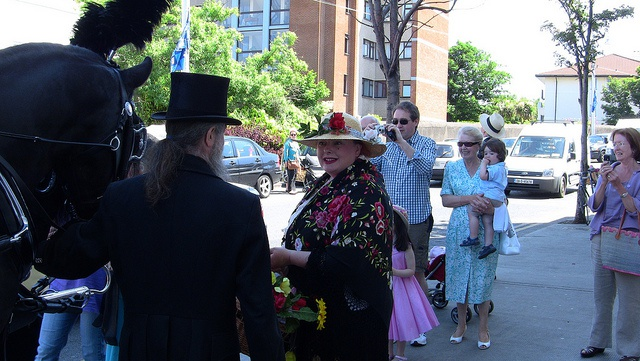Describe the objects in this image and their specific colors. I can see people in white, black, and gray tones, people in white, black, gray, maroon, and purple tones, horse in white, black, navy, darkblue, and gray tones, people in white, gray, darkblue, and navy tones, and people in white, lightblue, gray, and teal tones in this image. 